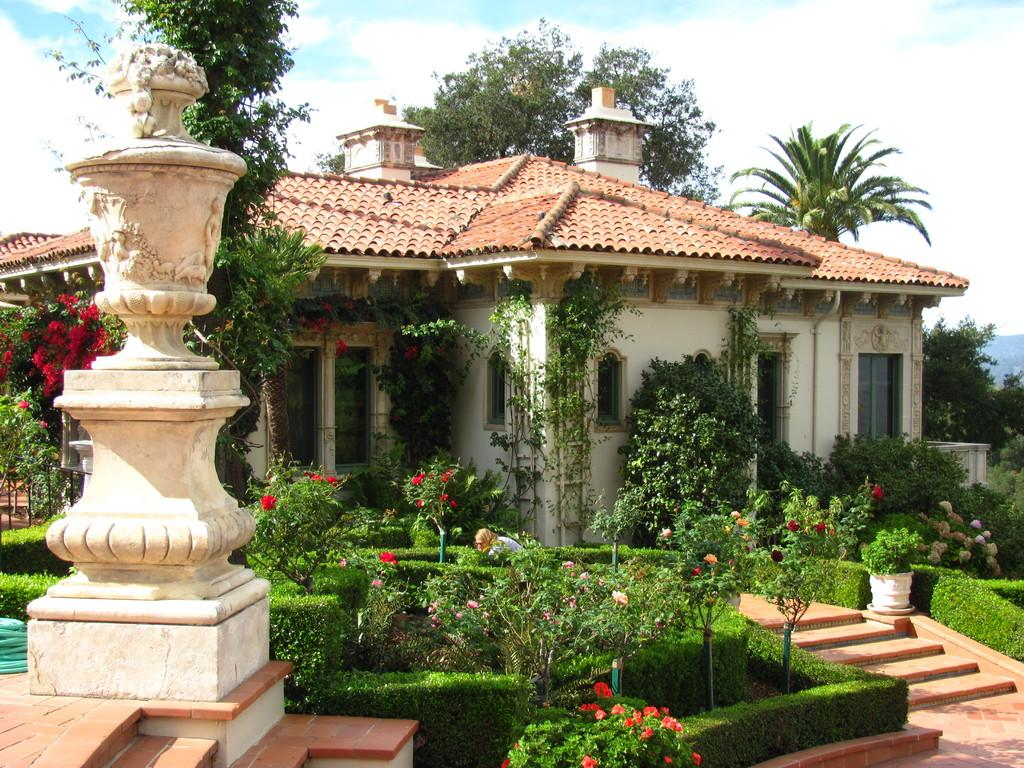What type of structure is visible in the image? There is a house in the image. What other natural elements can be seen in the image? There are plants and trees in the image. What word is being used in a game in the image? There is no game or word present in the image; it features a house, plants, and trees. What action is being performed by the house in the image? The house is a stationary structure and does not perform any actions in the image. 